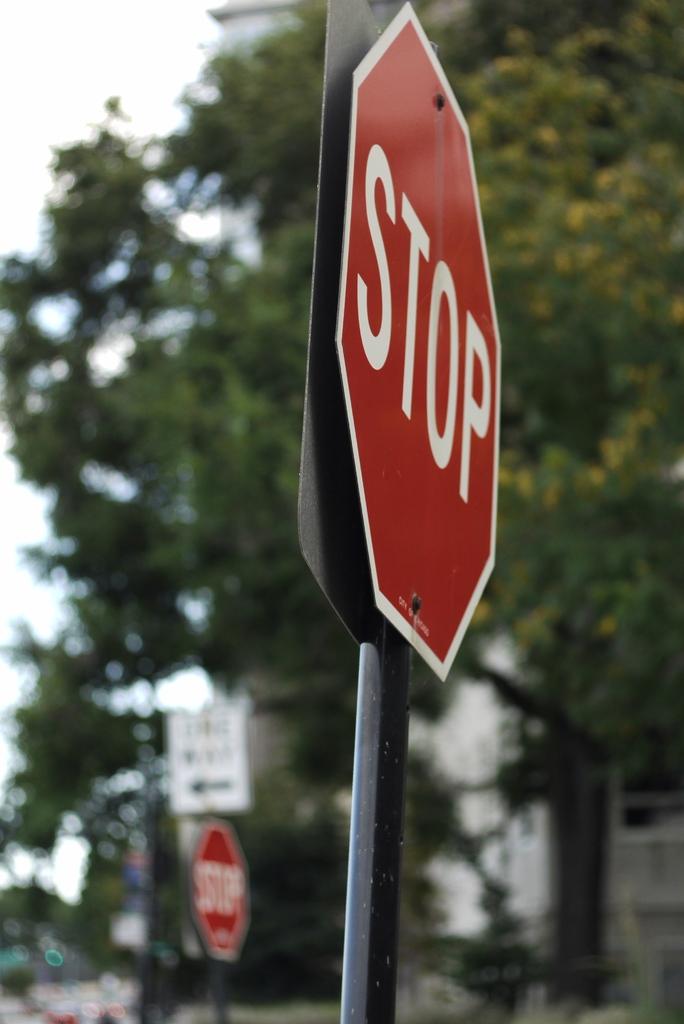What traffic sign is seen?
Your answer should be very brief. Stop. What does the sign with the arrow say?
Provide a short and direct response. One way. 